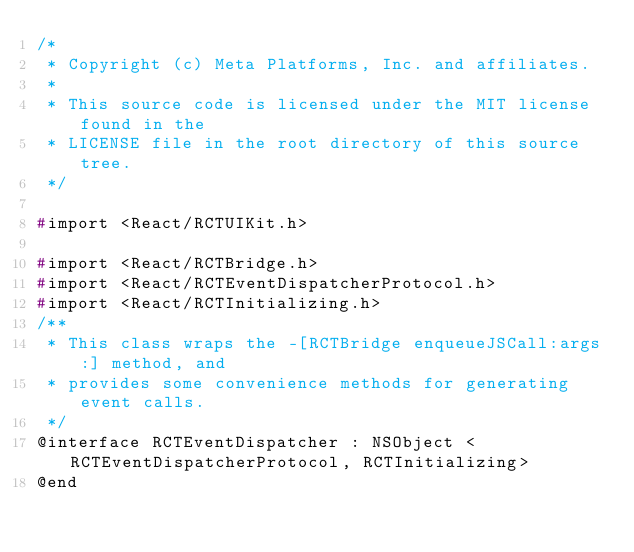<code> <loc_0><loc_0><loc_500><loc_500><_C_>/*
 * Copyright (c) Meta Platforms, Inc. and affiliates.
 *
 * This source code is licensed under the MIT license found in the
 * LICENSE file in the root directory of this source tree.
 */

#import <React/RCTUIKit.h>

#import <React/RCTBridge.h>
#import <React/RCTEventDispatcherProtocol.h>
#import <React/RCTInitializing.h>
/**
 * This class wraps the -[RCTBridge enqueueJSCall:args:] method, and
 * provides some convenience methods for generating event calls.
 */
@interface RCTEventDispatcher : NSObject <RCTEventDispatcherProtocol, RCTInitializing>
@end
</code> 